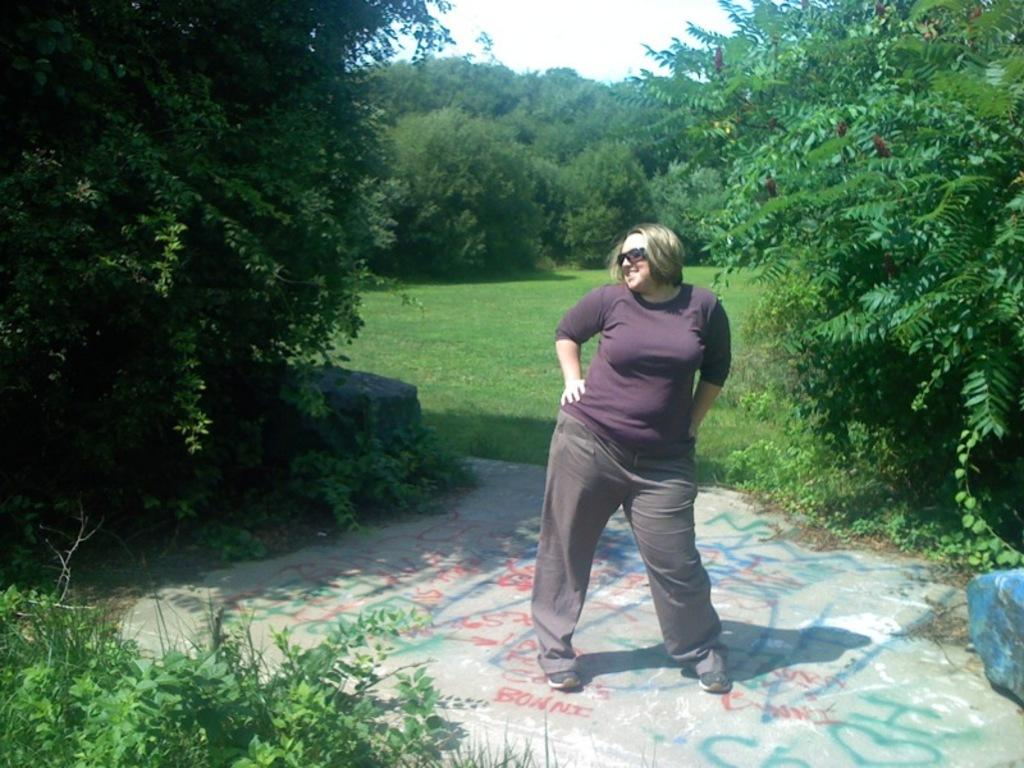What type of living organisms can be seen in the bottom left corner of the image? There are plants in the bottom left corner of the image. What is the main subject in the foreground of the image? There is a woman in the foreground of the image. What accessory is the woman wearing in the image? The woman is wearing glasses in the image. What can be seen in the background of the image? The background of the image is the sky. What type of toothbrush is the woman using in the image? There is no toothbrush present in the image. How does the woman sort the plants in the bottom left corner of the image? There is no sorting activity involving plants in the image. 